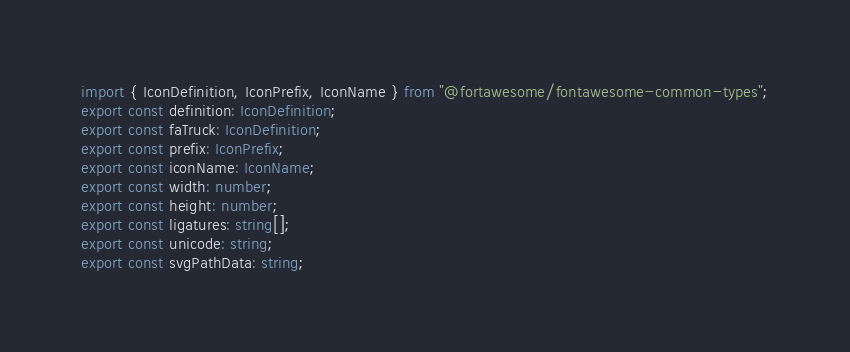Convert code to text. <code><loc_0><loc_0><loc_500><loc_500><_TypeScript_>import { IconDefinition, IconPrefix, IconName } from "@fortawesome/fontawesome-common-types";
export const definition: IconDefinition;
export const faTruck: IconDefinition;
export const prefix: IconPrefix;
export const iconName: IconName;
export const width: number;
export const height: number;
export const ligatures: string[];
export const unicode: string;
export const svgPathData: string;</code> 